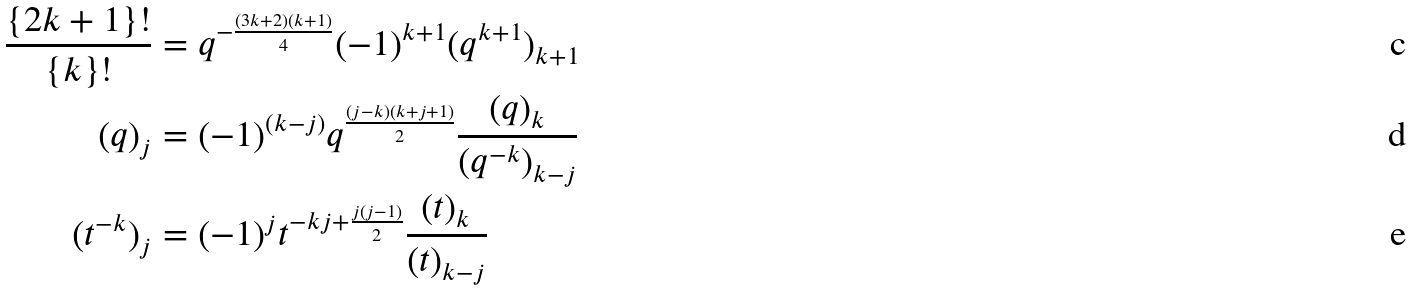<formula> <loc_0><loc_0><loc_500><loc_500>\frac { \{ 2 k + 1 \} ! } { \{ k \} ! } & = q ^ { - \frac { ( 3 k + 2 ) ( k + 1 ) } { 4 } } ( - 1 ) ^ { k + 1 } ( q ^ { k + 1 } ) _ { k + 1 } \\ ( q ) _ { j } & = ( - 1 ) ^ { ( k - j ) } q ^ { \frac { ( j - k ) ( k + j + 1 ) } { 2 } } \frac { ( q ) _ { k } } { ( q ^ { - k } ) _ { k - j } } \\ ( t ^ { - k } ) _ { j } & = ( - 1 ) ^ { j } t ^ { - k j + \frac { j ( j - 1 ) } { 2 } } \frac { ( t ) _ { k } } { ( t ) _ { k - j } }</formula> 